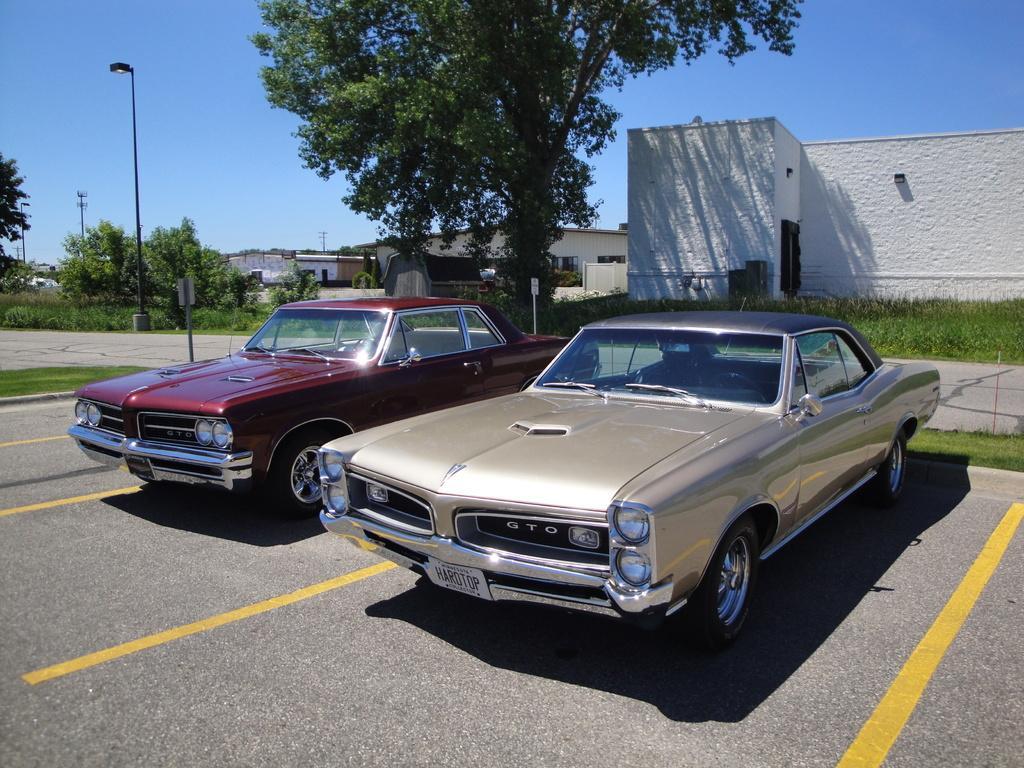In one or two sentences, can you explain what this image depicts? In this picture I can see few buildings and trees and few pole lights and couple of cars parked and I can see a blue sky. 